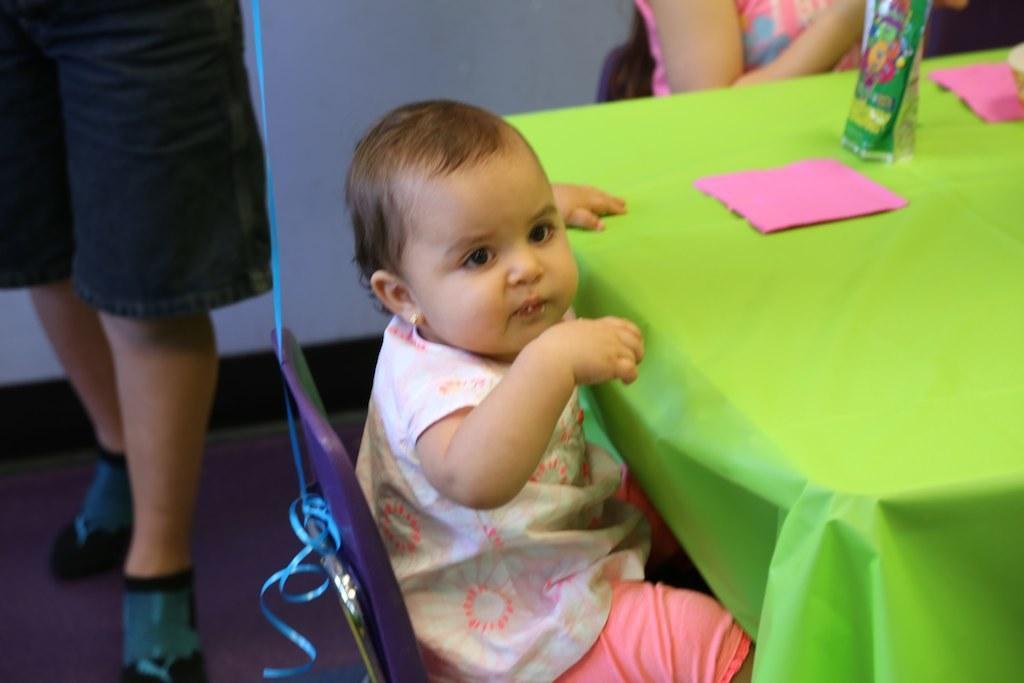Could you give a brief overview of what you see in this image? Here in this picture we can see a baby sitting on a chair with a table in the front and on that table we can see a vase present and we can also see other people present. 